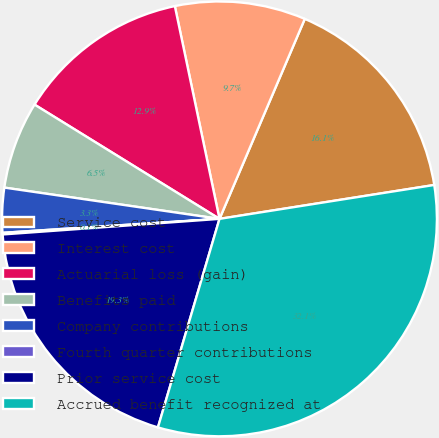Convert chart to OTSL. <chart><loc_0><loc_0><loc_500><loc_500><pie_chart><fcel>Service cost<fcel>Interest cost<fcel>Actuarial loss (gain)<fcel>Benefits paid<fcel>Company contributions<fcel>Fourth quarter contributions<fcel>Prior service cost<fcel>Accrued benefit recognized at<nl><fcel>16.09%<fcel>9.71%<fcel>12.9%<fcel>6.51%<fcel>3.32%<fcel>0.12%<fcel>19.29%<fcel>32.06%<nl></chart> 